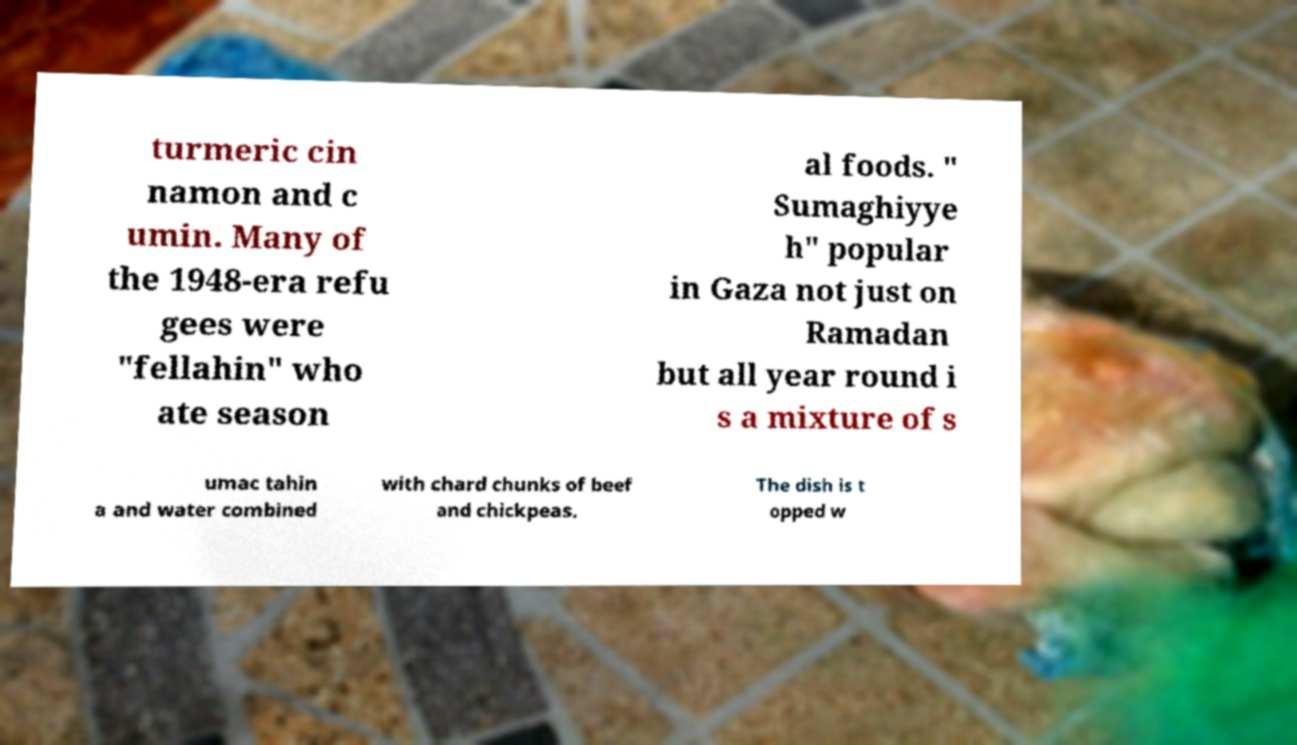Could you extract and type out the text from this image? turmeric cin namon and c umin. Many of the 1948-era refu gees were "fellahin" who ate season al foods. " Sumaghiyye h" popular in Gaza not just on Ramadan but all year round i s a mixture of s umac tahin a and water combined with chard chunks of beef and chickpeas. The dish is t opped w 